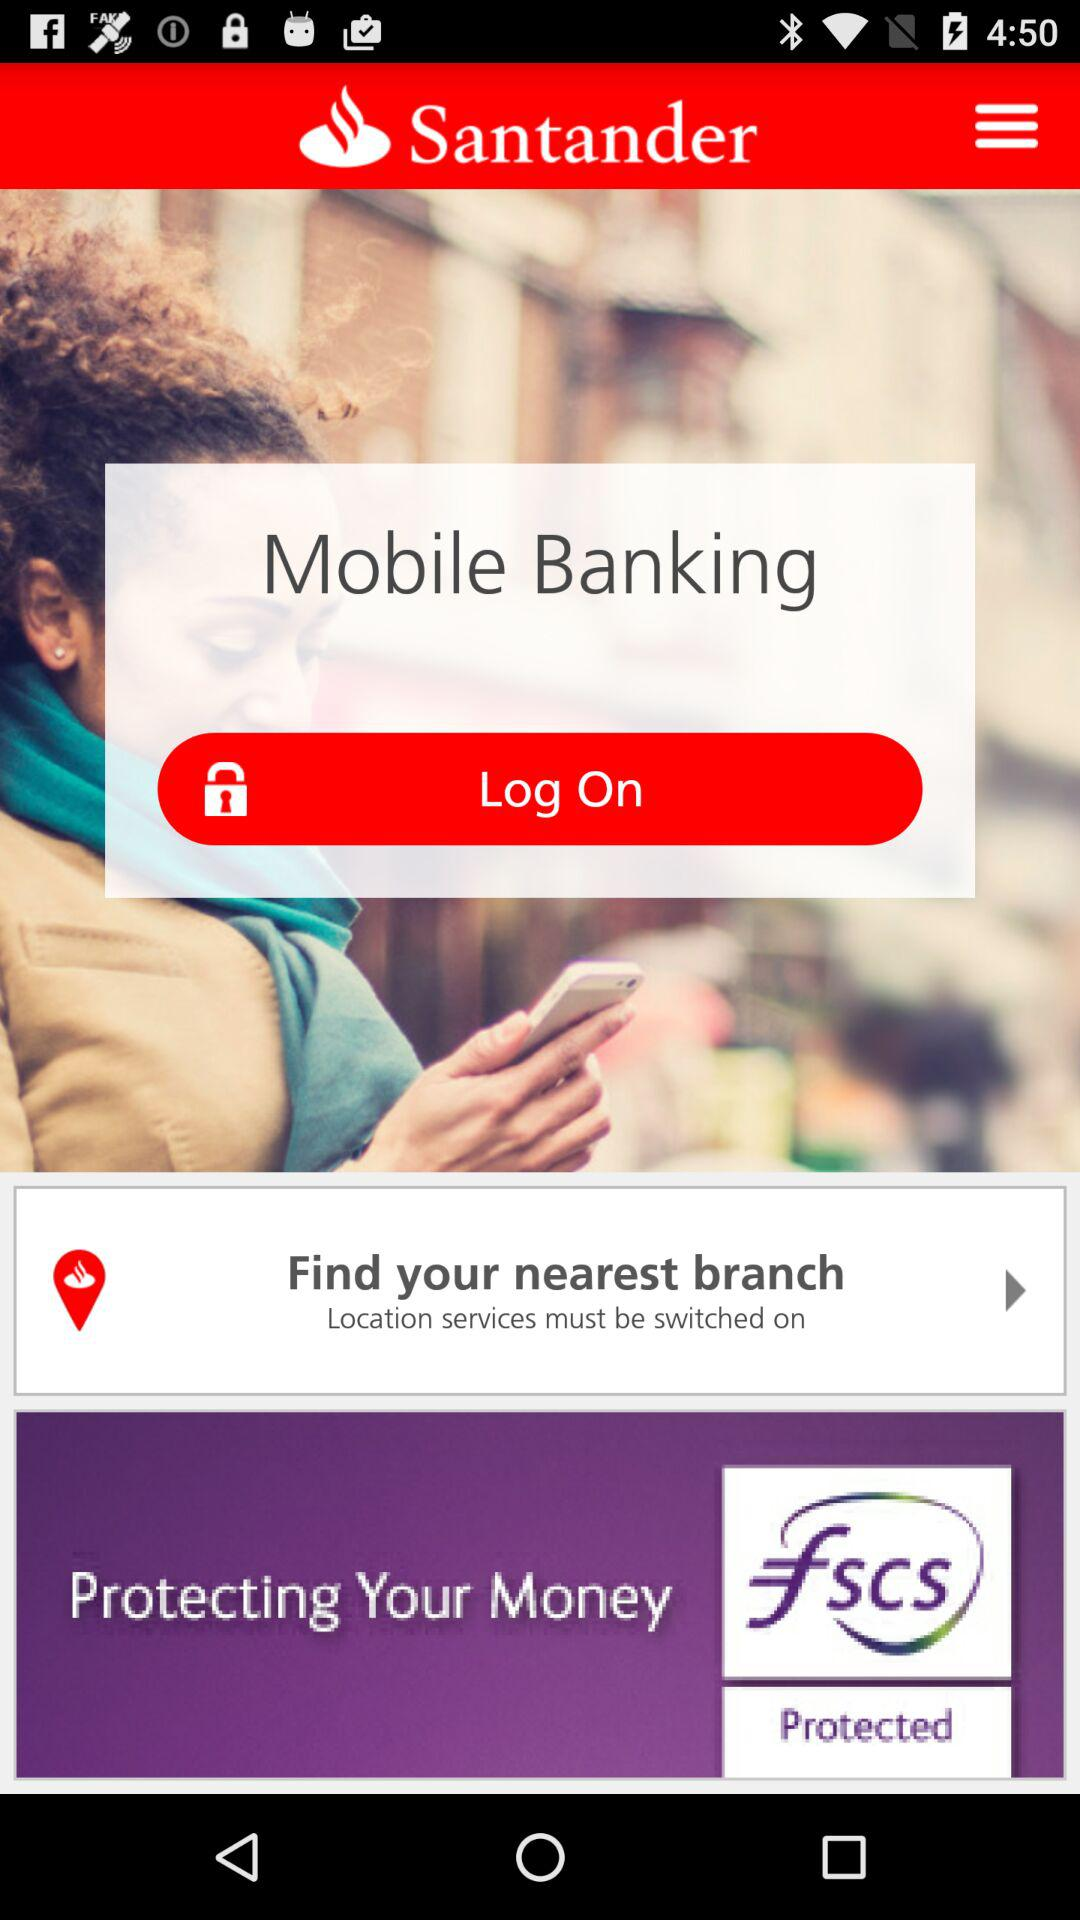How long does it take to log on?
When the provided information is insufficient, respond with <no answer>. <no answer> 